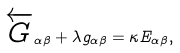<formula> <loc_0><loc_0><loc_500><loc_500>\overleftarrow { G } _ { \alpha \beta } + \lambda g _ { \alpha \beta } = \kappa E _ { \alpha \beta } ,</formula> 